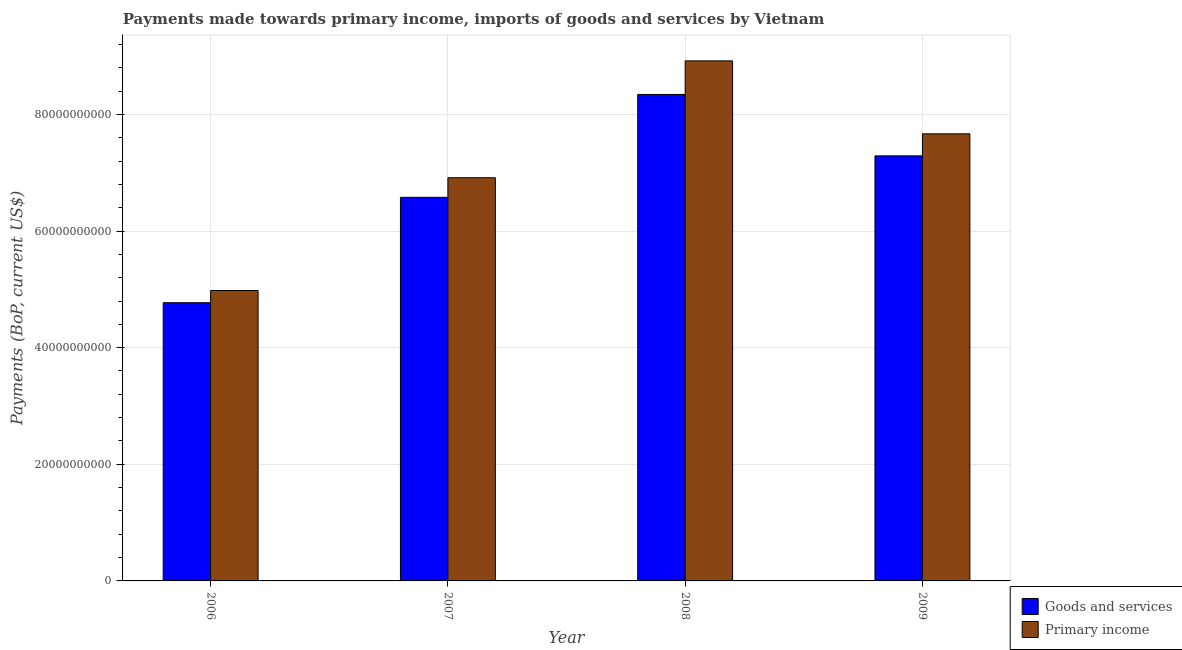How many groups of bars are there?
Your answer should be compact. 4. Are the number of bars on each tick of the X-axis equal?
Provide a short and direct response. Yes. How many bars are there on the 3rd tick from the left?
Provide a short and direct response. 2. How many bars are there on the 1st tick from the right?
Give a very brief answer. 2. In how many cases, is the number of bars for a given year not equal to the number of legend labels?
Keep it short and to the point. 0. What is the payments made towards primary income in 2007?
Offer a very short reply. 6.91e+1. Across all years, what is the maximum payments made towards primary income?
Your response must be concise. 8.92e+1. Across all years, what is the minimum payments made towards goods and services?
Make the answer very short. 4.77e+1. What is the total payments made towards primary income in the graph?
Provide a short and direct response. 2.85e+11. What is the difference between the payments made towards primary income in 2006 and that in 2009?
Your answer should be compact. -2.69e+1. What is the difference between the payments made towards goods and services in 2008 and the payments made towards primary income in 2007?
Give a very brief answer. 1.76e+1. What is the average payments made towards primary income per year?
Ensure brevity in your answer.  7.12e+1. What is the ratio of the payments made towards goods and services in 2008 to that in 2009?
Make the answer very short. 1.14. What is the difference between the highest and the second highest payments made towards primary income?
Provide a succinct answer. 1.25e+1. What is the difference between the highest and the lowest payments made towards goods and services?
Make the answer very short. 3.57e+1. In how many years, is the payments made towards primary income greater than the average payments made towards primary income taken over all years?
Provide a short and direct response. 2. Is the sum of the payments made towards goods and services in 2006 and 2008 greater than the maximum payments made towards primary income across all years?
Provide a succinct answer. Yes. What does the 2nd bar from the left in 2006 represents?
Your response must be concise. Primary income. What does the 1st bar from the right in 2009 represents?
Your answer should be compact. Primary income. How many bars are there?
Your response must be concise. 8. Does the graph contain any zero values?
Make the answer very short. No. Does the graph contain grids?
Offer a very short reply. Yes. Where does the legend appear in the graph?
Give a very brief answer. Bottom right. How are the legend labels stacked?
Your response must be concise. Vertical. What is the title of the graph?
Keep it short and to the point. Payments made towards primary income, imports of goods and services by Vietnam. Does "Arms imports" appear as one of the legend labels in the graph?
Make the answer very short. No. What is the label or title of the X-axis?
Provide a succinct answer. Year. What is the label or title of the Y-axis?
Provide a short and direct response. Payments (BoP, current US$). What is the Payments (BoP, current US$) of Goods and services in 2006?
Your answer should be very brief. 4.77e+1. What is the Payments (BoP, current US$) in Primary income in 2006?
Your answer should be very brief. 4.98e+1. What is the Payments (BoP, current US$) of Goods and services in 2007?
Provide a succinct answer. 6.58e+1. What is the Payments (BoP, current US$) in Primary income in 2007?
Offer a terse response. 6.91e+1. What is the Payments (BoP, current US$) in Goods and services in 2008?
Provide a succinct answer. 8.34e+1. What is the Payments (BoP, current US$) in Primary income in 2008?
Your answer should be compact. 8.92e+1. What is the Payments (BoP, current US$) in Goods and services in 2009?
Your response must be concise. 7.29e+1. What is the Payments (BoP, current US$) of Primary income in 2009?
Your answer should be compact. 7.67e+1. Across all years, what is the maximum Payments (BoP, current US$) in Goods and services?
Provide a succinct answer. 8.34e+1. Across all years, what is the maximum Payments (BoP, current US$) of Primary income?
Offer a terse response. 8.92e+1. Across all years, what is the minimum Payments (BoP, current US$) of Goods and services?
Offer a very short reply. 4.77e+1. Across all years, what is the minimum Payments (BoP, current US$) of Primary income?
Give a very brief answer. 4.98e+1. What is the total Payments (BoP, current US$) of Goods and services in the graph?
Give a very brief answer. 2.70e+11. What is the total Payments (BoP, current US$) in Primary income in the graph?
Your answer should be very brief. 2.85e+11. What is the difference between the Payments (BoP, current US$) in Goods and services in 2006 and that in 2007?
Your response must be concise. -1.81e+1. What is the difference between the Payments (BoP, current US$) in Primary income in 2006 and that in 2007?
Offer a terse response. -1.93e+1. What is the difference between the Payments (BoP, current US$) in Goods and services in 2006 and that in 2008?
Provide a succinct answer. -3.57e+1. What is the difference between the Payments (BoP, current US$) of Primary income in 2006 and that in 2008?
Provide a succinct answer. -3.94e+1. What is the difference between the Payments (BoP, current US$) of Goods and services in 2006 and that in 2009?
Provide a short and direct response. -2.52e+1. What is the difference between the Payments (BoP, current US$) in Primary income in 2006 and that in 2009?
Offer a terse response. -2.69e+1. What is the difference between the Payments (BoP, current US$) in Goods and services in 2007 and that in 2008?
Your response must be concise. -1.76e+1. What is the difference between the Payments (BoP, current US$) in Primary income in 2007 and that in 2008?
Your answer should be very brief. -2.00e+1. What is the difference between the Payments (BoP, current US$) of Goods and services in 2007 and that in 2009?
Offer a terse response. -7.11e+09. What is the difference between the Payments (BoP, current US$) of Primary income in 2007 and that in 2009?
Offer a terse response. -7.53e+09. What is the difference between the Payments (BoP, current US$) of Goods and services in 2008 and that in 2009?
Ensure brevity in your answer.  1.05e+1. What is the difference between the Payments (BoP, current US$) of Primary income in 2008 and that in 2009?
Make the answer very short. 1.25e+1. What is the difference between the Payments (BoP, current US$) in Goods and services in 2006 and the Payments (BoP, current US$) in Primary income in 2007?
Provide a succinct answer. -2.14e+1. What is the difference between the Payments (BoP, current US$) of Goods and services in 2006 and the Payments (BoP, current US$) of Primary income in 2008?
Ensure brevity in your answer.  -4.15e+1. What is the difference between the Payments (BoP, current US$) in Goods and services in 2006 and the Payments (BoP, current US$) in Primary income in 2009?
Make the answer very short. -2.90e+1. What is the difference between the Payments (BoP, current US$) in Goods and services in 2007 and the Payments (BoP, current US$) in Primary income in 2008?
Your response must be concise. -2.34e+1. What is the difference between the Payments (BoP, current US$) in Goods and services in 2007 and the Payments (BoP, current US$) in Primary income in 2009?
Offer a very short reply. -1.09e+1. What is the difference between the Payments (BoP, current US$) in Goods and services in 2008 and the Payments (BoP, current US$) in Primary income in 2009?
Ensure brevity in your answer.  6.75e+09. What is the average Payments (BoP, current US$) of Goods and services per year?
Your answer should be compact. 6.75e+1. What is the average Payments (BoP, current US$) in Primary income per year?
Keep it short and to the point. 7.12e+1. In the year 2006, what is the difference between the Payments (BoP, current US$) in Goods and services and Payments (BoP, current US$) in Primary income?
Provide a short and direct response. -2.10e+09. In the year 2007, what is the difference between the Payments (BoP, current US$) in Goods and services and Payments (BoP, current US$) in Primary income?
Offer a very short reply. -3.36e+09. In the year 2008, what is the difference between the Payments (BoP, current US$) of Goods and services and Payments (BoP, current US$) of Primary income?
Offer a terse response. -5.76e+09. In the year 2009, what is the difference between the Payments (BoP, current US$) of Goods and services and Payments (BoP, current US$) of Primary income?
Keep it short and to the point. -3.78e+09. What is the ratio of the Payments (BoP, current US$) in Goods and services in 2006 to that in 2007?
Offer a very short reply. 0.73. What is the ratio of the Payments (BoP, current US$) in Primary income in 2006 to that in 2007?
Your answer should be compact. 0.72. What is the ratio of the Payments (BoP, current US$) in Goods and services in 2006 to that in 2008?
Your answer should be very brief. 0.57. What is the ratio of the Payments (BoP, current US$) of Primary income in 2006 to that in 2008?
Keep it short and to the point. 0.56. What is the ratio of the Payments (BoP, current US$) of Goods and services in 2006 to that in 2009?
Provide a short and direct response. 0.65. What is the ratio of the Payments (BoP, current US$) of Primary income in 2006 to that in 2009?
Give a very brief answer. 0.65. What is the ratio of the Payments (BoP, current US$) of Goods and services in 2007 to that in 2008?
Offer a terse response. 0.79. What is the ratio of the Payments (BoP, current US$) in Primary income in 2007 to that in 2008?
Keep it short and to the point. 0.78. What is the ratio of the Payments (BoP, current US$) in Goods and services in 2007 to that in 2009?
Offer a very short reply. 0.9. What is the ratio of the Payments (BoP, current US$) in Primary income in 2007 to that in 2009?
Offer a terse response. 0.9. What is the ratio of the Payments (BoP, current US$) of Goods and services in 2008 to that in 2009?
Your response must be concise. 1.14. What is the ratio of the Payments (BoP, current US$) of Primary income in 2008 to that in 2009?
Your answer should be compact. 1.16. What is the difference between the highest and the second highest Payments (BoP, current US$) in Goods and services?
Your response must be concise. 1.05e+1. What is the difference between the highest and the second highest Payments (BoP, current US$) in Primary income?
Your answer should be very brief. 1.25e+1. What is the difference between the highest and the lowest Payments (BoP, current US$) in Goods and services?
Your response must be concise. 3.57e+1. What is the difference between the highest and the lowest Payments (BoP, current US$) of Primary income?
Offer a terse response. 3.94e+1. 